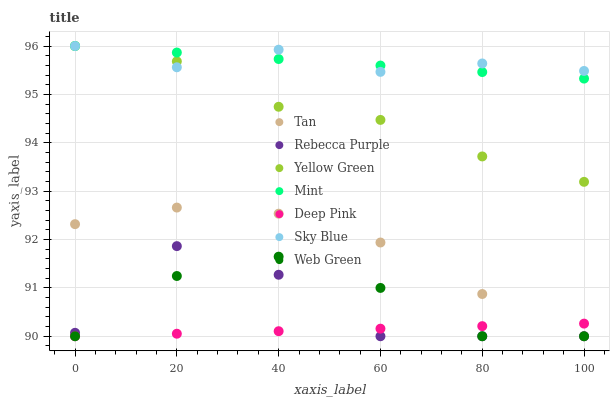Does Deep Pink have the minimum area under the curve?
Answer yes or no. Yes. Does Sky Blue have the maximum area under the curve?
Answer yes or no. Yes. Does Yellow Green have the minimum area under the curve?
Answer yes or no. No. Does Yellow Green have the maximum area under the curve?
Answer yes or no. No. Is Deep Pink the smoothest?
Answer yes or no. Yes. Is Rebecca Purple the roughest?
Answer yes or no. Yes. Is Yellow Green the smoothest?
Answer yes or no. No. Is Yellow Green the roughest?
Answer yes or no. No. Does Deep Pink have the lowest value?
Answer yes or no. Yes. Does Yellow Green have the lowest value?
Answer yes or no. No. Does Mint have the highest value?
Answer yes or no. Yes. Does Web Green have the highest value?
Answer yes or no. No. Is Rebecca Purple less than Sky Blue?
Answer yes or no. Yes. Is Mint greater than Deep Pink?
Answer yes or no. Yes. Does Web Green intersect Rebecca Purple?
Answer yes or no. Yes. Is Web Green less than Rebecca Purple?
Answer yes or no. No. Is Web Green greater than Rebecca Purple?
Answer yes or no. No. Does Rebecca Purple intersect Sky Blue?
Answer yes or no. No. 